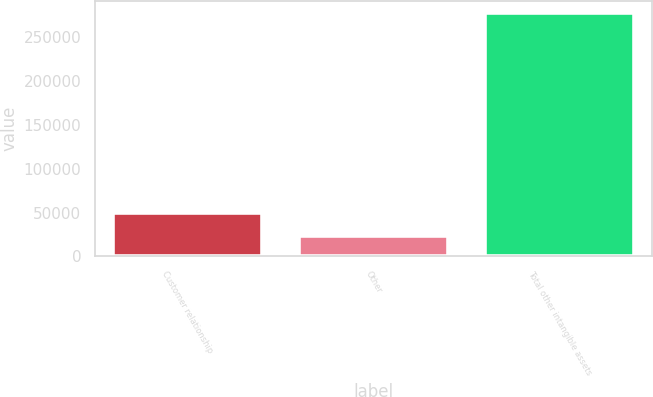Convert chart to OTSL. <chart><loc_0><loc_0><loc_500><loc_500><bar_chart><fcel>Customer relationship<fcel>Other<fcel>Total other intangible assets<nl><fcel>49308.2<fcel>23902<fcel>277964<nl></chart> 